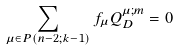Convert formula to latex. <formula><loc_0><loc_0><loc_500><loc_500>\sum _ { \mu \in P ( n - 2 ; k - 1 ) } f _ { \mu } Q _ { D } ^ { \mu ; m } = 0</formula> 